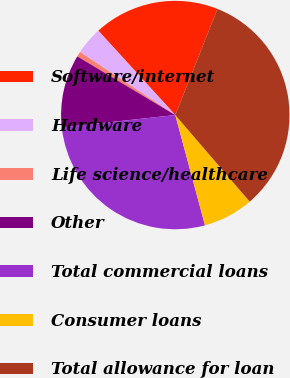Convert chart. <chart><loc_0><loc_0><loc_500><loc_500><pie_chart><fcel>Software/internet<fcel>Hardware<fcel>Life science/healthcare<fcel>Other<fcel>Total commercial loans<fcel>Consumer loans<fcel>Total allowance for loan<nl><fcel>17.79%<fcel>3.92%<fcel>0.72%<fcel>10.31%<fcel>27.46%<fcel>7.11%<fcel>32.68%<nl></chart> 